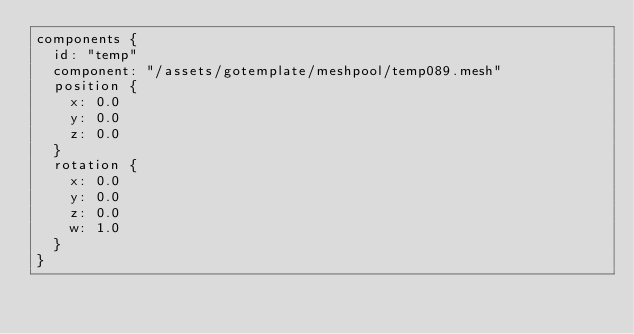<code> <loc_0><loc_0><loc_500><loc_500><_Go_>components {
  id: "temp"
  component: "/assets/gotemplate/meshpool/temp089.mesh"
  position {
    x: 0.0
    y: 0.0
    z: 0.0
  }
  rotation {
    x: 0.0
    y: 0.0
    z: 0.0
    w: 1.0
  }
}
</code> 